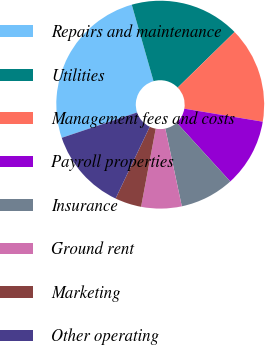Convert chart. <chart><loc_0><loc_0><loc_500><loc_500><pie_chart><fcel>Repairs and maintenance<fcel>Utilities<fcel>Management fees and costs<fcel>Payroll properties<fcel>Insurance<fcel>Ground rent<fcel>Marketing<fcel>Other operating<nl><fcel>25.76%<fcel>17.1%<fcel>14.94%<fcel>10.61%<fcel>8.44%<fcel>6.28%<fcel>4.11%<fcel>12.77%<nl></chart> 